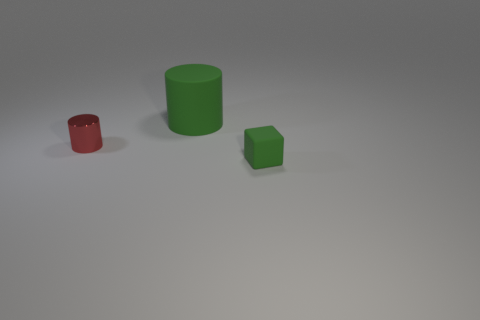What color is the cylinder that is the same size as the block?
Make the answer very short. Red. What number of tiny things are either cylinders or brown matte objects?
Your answer should be very brief. 1. Are there an equal number of objects that are to the right of the green cylinder and green rubber objects that are in front of the tiny red shiny thing?
Ensure brevity in your answer.  Yes. What number of red shiny things have the same size as the green block?
Offer a terse response. 1. What number of gray things are either shiny things or matte cubes?
Provide a short and direct response. 0. Are there an equal number of small shiny cylinders on the left side of the small cylinder and metallic balls?
Make the answer very short. Yes. How big is the thing left of the large green rubber object?
Your response must be concise. Small. How many other small red metal things are the same shape as the tiny red metallic thing?
Offer a very short reply. 0. There is a object that is right of the tiny red object and behind the small green thing; what material is it?
Make the answer very short. Rubber. Is the tiny red cylinder made of the same material as the small green block?
Offer a very short reply. No. 